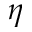<formula> <loc_0><loc_0><loc_500><loc_500>\eta</formula> 